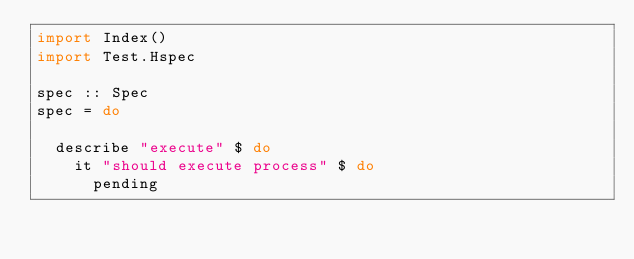Convert code to text. <code><loc_0><loc_0><loc_500><loc_500><_Haskell_>import Index()
import Test.Hspec

spec :: Spec
spec = do

  describe "execute" $ do
    it "should execute process" $ do
      pending
</code> 